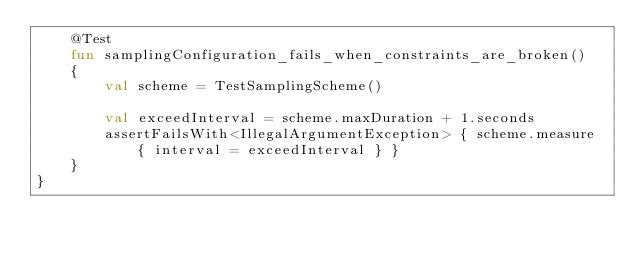<code> <loc_0><loc_0><loc_500><loc_500><_Kotlin_>    @Test
    fun samplingConfiguration_fails_when_constraints_are_broken()
    {
        val scheme = TestSamplingScheme()

        val exceedInterval = scheme.maxDuration + 1.seconds
        assertFailsWith<IllegalArgumentException> { scheme.measure { interval = exceedInterval } }
    }
}
</code> 